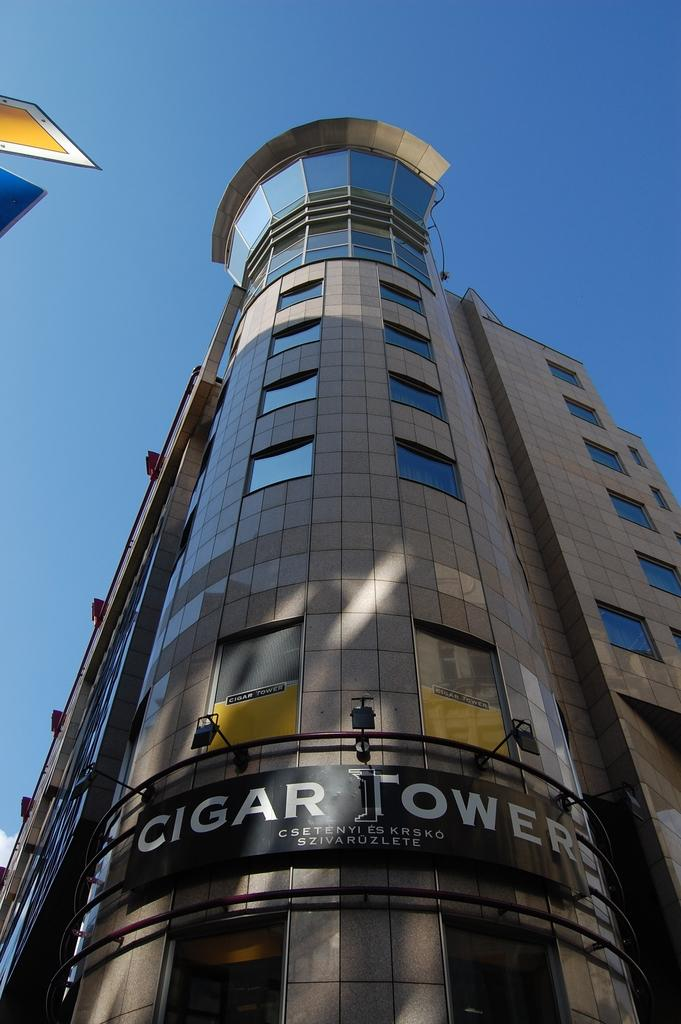What type of structure is present in the image? There is a building in the image. What features can be observed on the building? The building has windows and lights. Is there any signage on the building? Yes, there is a name board on the building. What can be seen in the background of the image? The sky is visible behind the building. What objects are on the left side of the image? There are two objects on the left side of the image. Can you describe the fight between the baby and the example in the image? There is no fight, baby, or example present in the image. 